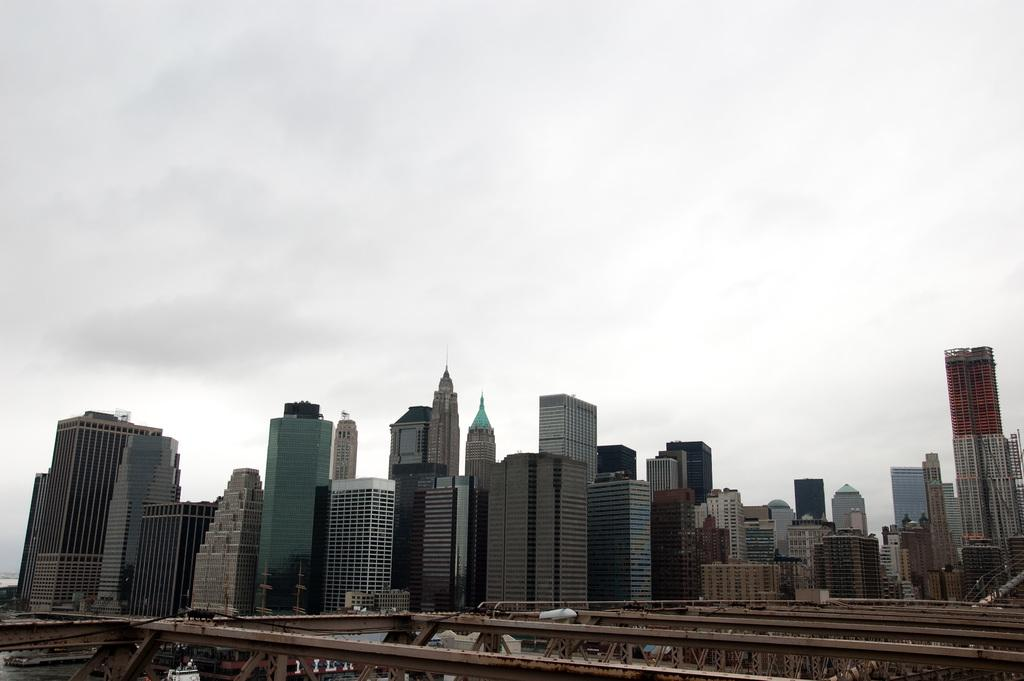What type of structures can be seen in the image? There are many buildings in the image. What else can be seen near the water on the left side of the image? There are boats on the water to the left of the image. What is visible in the background of the image? There are clouds and the sky visible in the background of the image. How long does it take for the horse to complete the addition problem in the image? There is no horse or addition problem present in the image. 